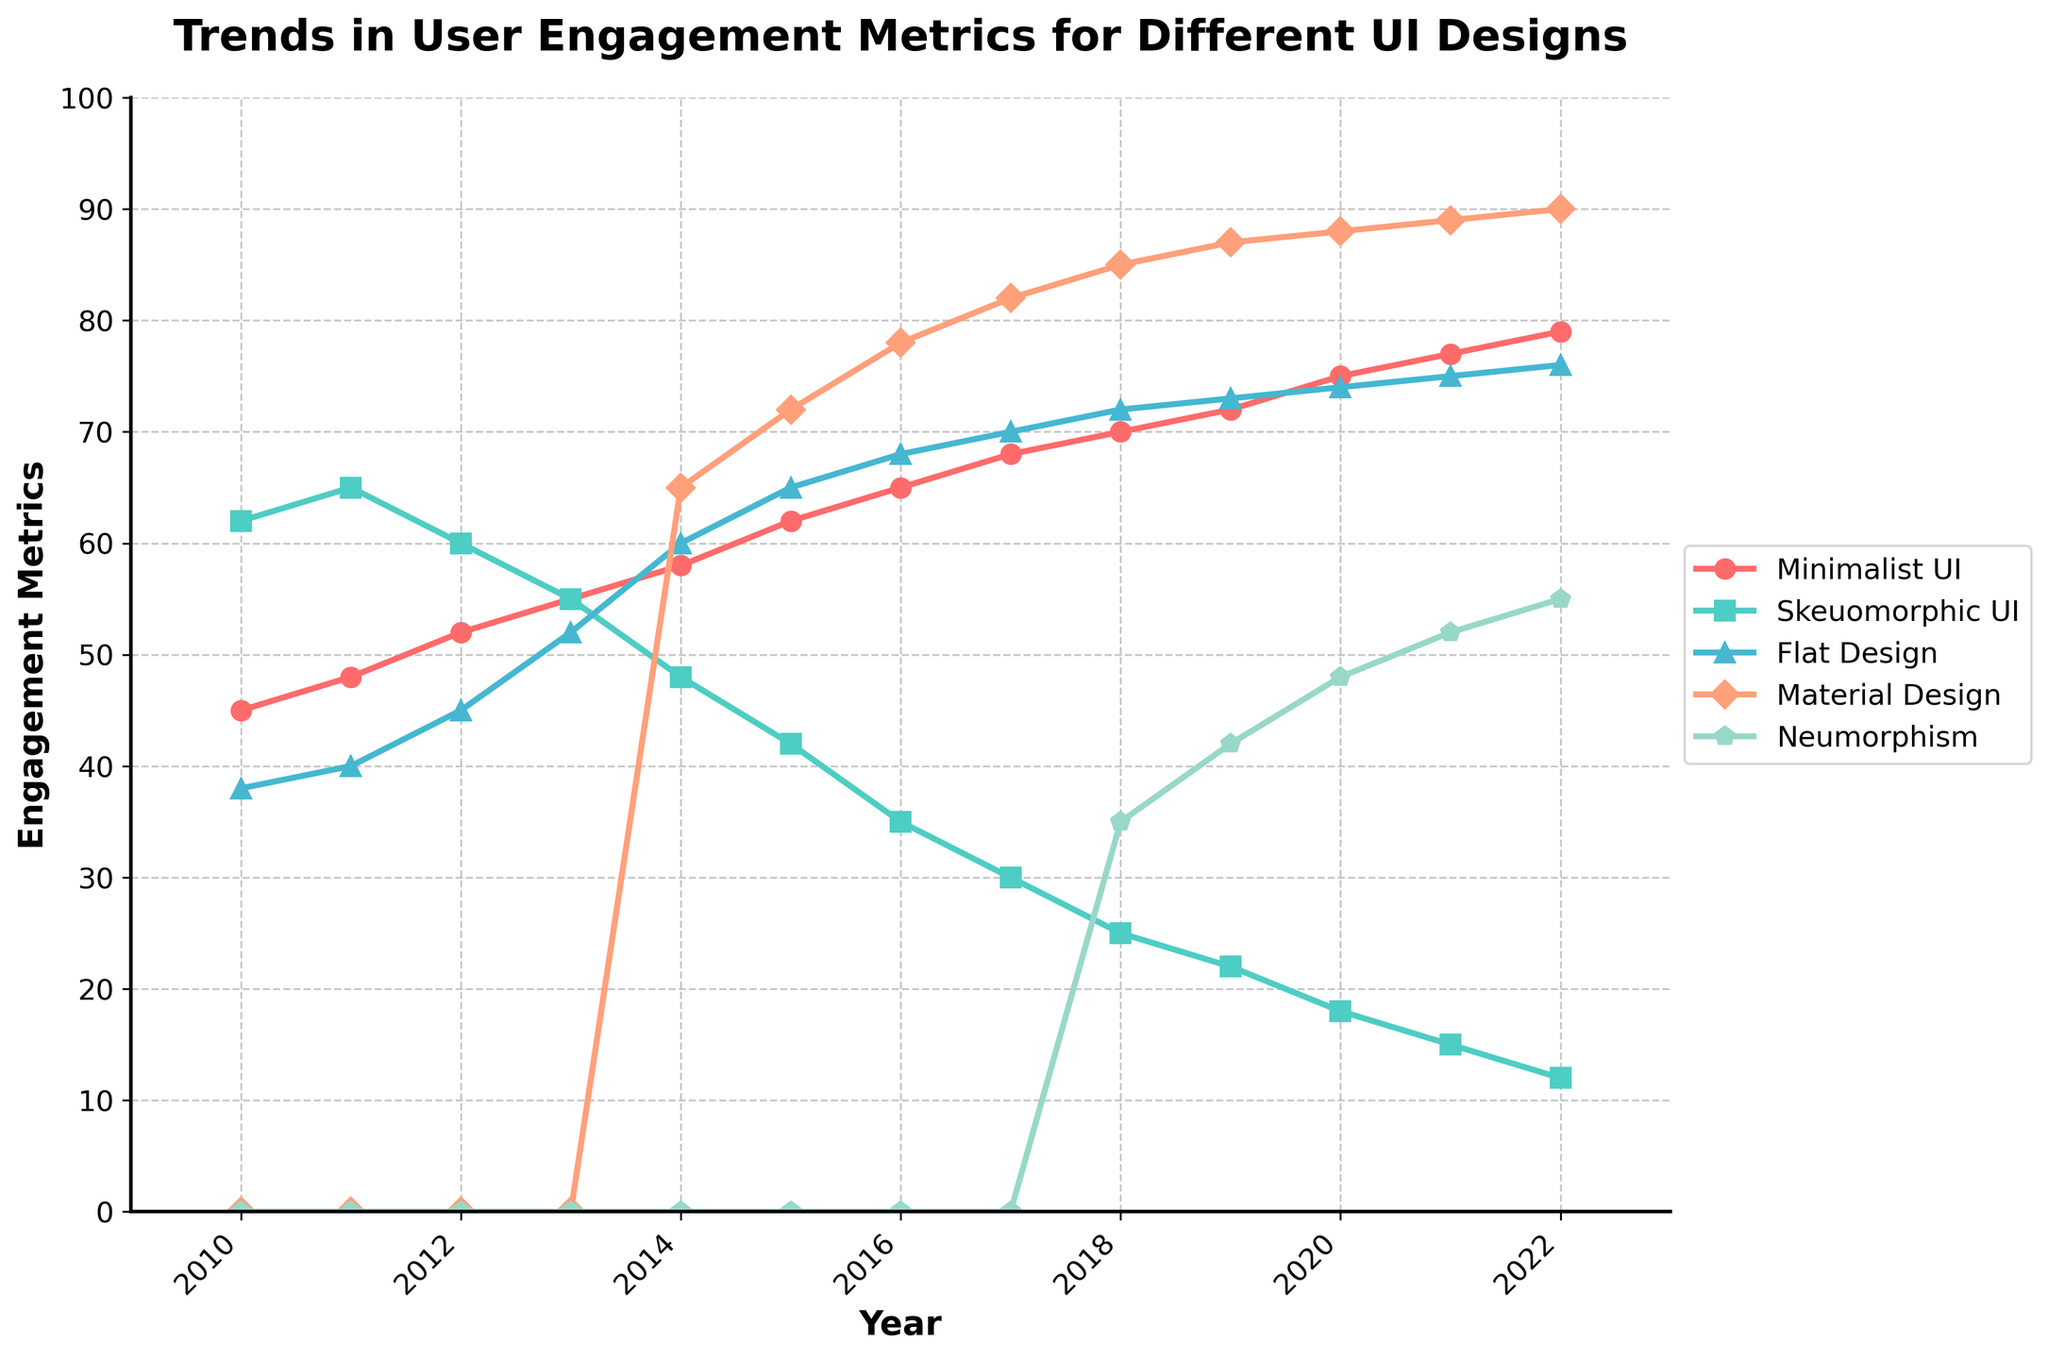which UI design has the highest engagement metric in 2022? Look at the endpoints of each line for the year 2022 and identify the one reaching the highest value on the y-axis.
Answer: Material Design which UI design showed the most significant drop in engagement metrics between 2010 and 2022? Calculate the difference between the engagement metrics in 2010 and 2022 for each UI design. The largest negative difference indicates the most significant drop. Skeuomorphic UI: 62 - 12 = 50 drop
Answer: Skeuomorphic UI which UI designs were introduced after 2014? Identify the UI designs that start from non-zero values at years later than 2014.
Answer: Material Design and Neumorphism what is the average engagement metric for Minimalist UI across all the years? Sum the engagement metrics of Minimalist UI from 2010 to 2022 and divide by the number of years: (45+48+52+55+58+62+65+68+70+72+75+77+79) / 13
Answer: 62 which UI design had the least engagement metric in 2016? Check the value for each UI design in 2016 and identify the smallest value.
Answer: Skeuomorphic UI how does the growth trend of Flat Design compare to Neumorphism from 2018 onwards? Observe the slope of the lines for Flat Design and Neumorphism starting from 2018. Neumorphism starts from 35 in 2018 and goes up to 55 in 2022, while Flat Design starts from 72 in 2018 and goes up to 76 in 2022.
Answer: Neumorphism grew more which year did Material Design surpass Skeuomorphic UI in engagement metrics? Find the point where the Material Design line crosses above the Skeuomorphic UI line. This happens between 2014 and 2015.
Answer: 2014 what is the overall trend for Minimalist UI from 2010 to 2022? Observe the Minimalist UI line from start to end; note whether it is generally increasing, decreasing, or flat.
Answer: Increasing comparing the year 2013, which UI design had the closest engagement metrics to Minimalist UI? Look at the values for 2013 and find the UI design with the value closest to Minimalist UI's value of 55.
Answer: Flat Design - 52 what is the percentage change in engagement metrics for Material Design from 2014 to 2022? Calculate the percentage increase from 65 in 2014 to 90 in 2022: ((90 - 65) / 65) * 100 = 38.46%
Answer: 38.46% what is the visual difference in trend between Skeuomorphic UI and Material Design from 2010 to 2015? Compare the slope of the lines for these two UIs over the specified period. Skeuomorphic UI is decreasing, while Material Design is increasing.
Answer: Skeuomorphic UI is decreasing, Material Design is increasing 